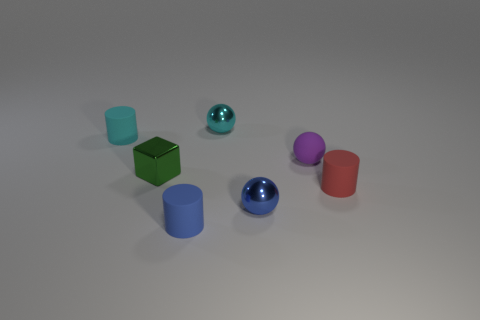What is the shape of the small metallic object that is to the right of the tiny metallic ball behind the small purple matte sphere that is behind the blue rubber cylinder?
Offer a very short reply. Sphere. There is a tiny metallic object that is both behind the small red rubber thing and in front of the small purple matte thing; what is its shape?
Ensure brevity in your answer.  Cube. How many things are either blue objects or things that are to the right of the small shiny block?
Give a very brief answer. 5. Are the blue ball and the small green cube made of the same material?
Give a very brief answer. Yes. How many other things are there of the same shape as the cyan matte thing?
Give a very brief answer. 2. What size is the rubber cylinder that is both on the left side of the blue ball and behind the tiny blue metallic ball?
Give a very brief answer. Small. What number of matte things are green blocks or small yellow cylinders?
Give a very brief answer. 0. There is a cyan object that is in front of the small cyan sphere; does it have the same shape as the tiny green thing to the left of the small purple matte thing?
Provide a short and direct response. No. Is there a tiny cyan ball that has the same material as the cube?
Offer a very short reply. Yes. What is the color of the matte ball?
Ensure brevity in your answer.  Purple. 